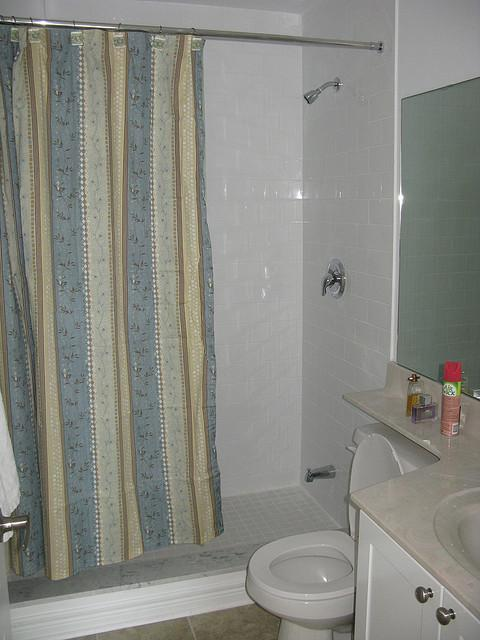What is in the can on the counter?

Choices:
A) fake tan
B) paint
C) air freshener
D) hairspray air freshener 